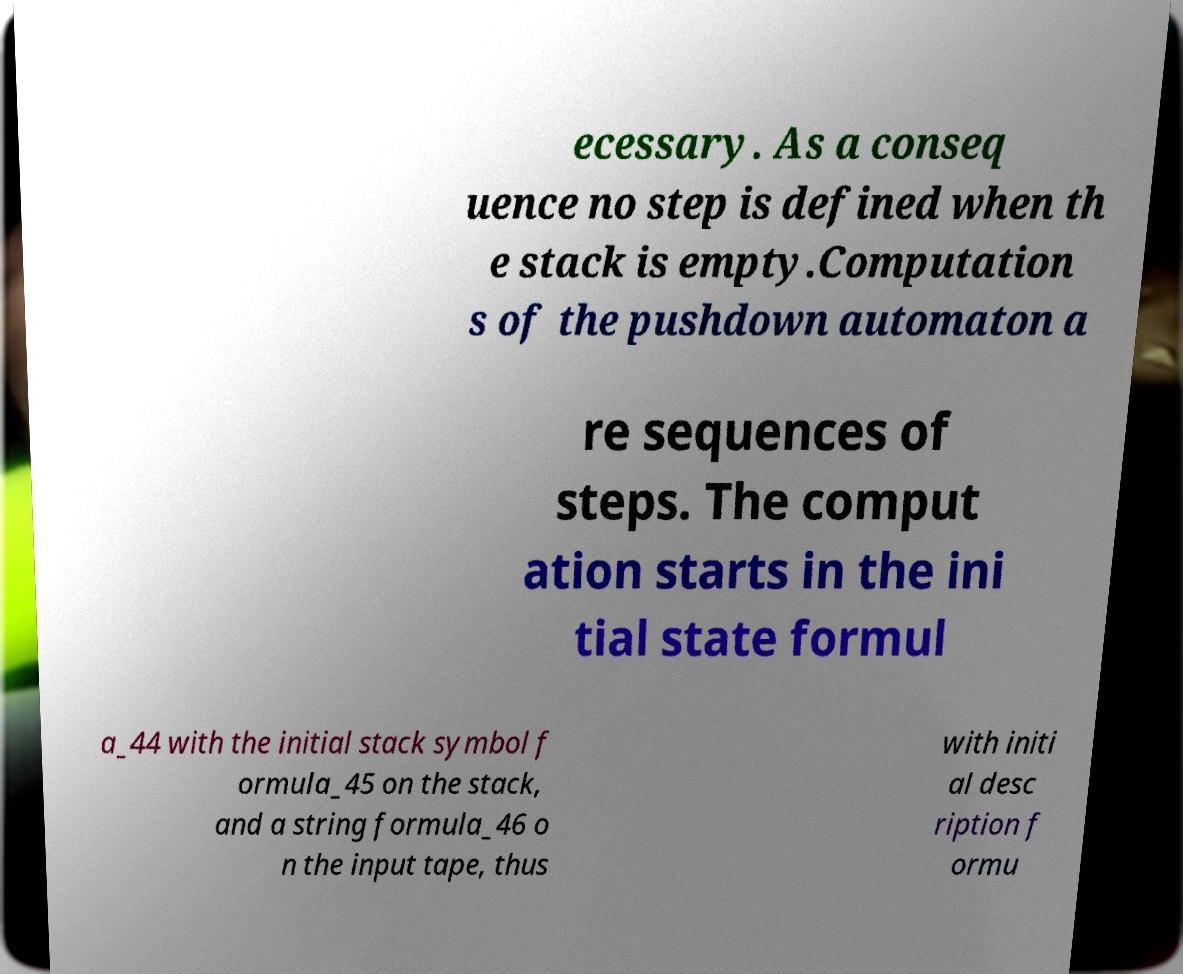What messages or text are displayed in this image? I need them in a readable, typed format. ecessary. As a conseq uence no step is defined when th e stack is empty.Computation s of the pushdown automaton a re sequences of steps. The comput ation starts in the ini tial state formul a_44 with the initial stack symbol f ormula_45 on the stack, and a string formula_46 o n the input tape, thus with initi al desc ription f ormu 